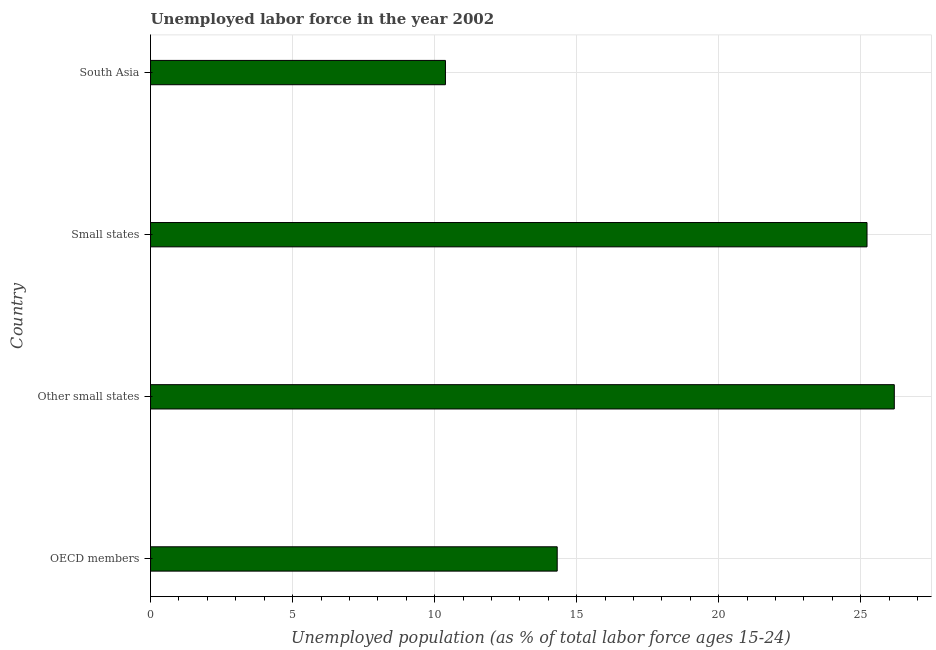Does the graph contain grids?
Your answer should be very brief. Yes. What is the title of the graph?
Give a very brief answer. Unemployed labor force in the year 2002. What is the label or title of the X-axis?
Ensure brevity in your answer.  Unemployed population (as % of total labor force ages 15-24). What is the label or title of the Y-axis?
Give a very brief answer. Country. What is the total unemployed youth population in Other small states?
Offer a very short reply. 26.18. Across all countries, what is the maximum total unemployed youth population?
Make the answer very short. 26.18. Across all countries, what is the minimum total unemployed youth population?
Your response must be concise. 10.38. In which country was the total unemployed youth population maximum?
Your answer should be compact. Other small states. What is the sum of the total unemployed youth population?
Your response must be concise. 76.09. What is the difference between the total unemployed youth population in OECD members and South Asia?
Your answer should be very brief. 3.93. What is the average total unemployed youth population per country?
Ensure brevity in your answer.  19.02. What is the median total unemployed youth population?
Your response must be concise. 19.77. What is the ratio of the total unemployed youth population in OECD members to that in Other small states?
Make the answer very short. 0.55. Is the total unemployed youth population in OECD members less than that in Other small states?
Keep it short and to the point. Yes. Are all the bars in the graph horizontal?
Provide a short and direct response. Yes. What is the difference between two consecutive major ticks on the X-axis?
Your response must be concise. 5. What is the Unemployed population (as % of total labor force ages 15-24) in OECD members?
Provide a succinct answer. 14.31. What is the Unemployed population (as % of total labor force ages 15-24) of Other small states?
Ensure brevity in your answer.  26.18. What is the Unemployed population (as % of total labor force ages 15-24) in Small states?
Provide a succinct answer. 25.22. What is the Unemployed population (as % of total labor force ages 15-24) of South Asia?
Provide a short and direct response. 10.38. What is the difference between the Unemployed population (as % of total labor force ages 15-24) in OECD members and Other small states?
Ensure brevity in your answer.  -11.87. What is the difference between the Unemployed population (as % of total labor force ages 15-24) in OECD members and Small states?
Offer a terse response. -10.91. What is the difference between the Unemployed population (as % of total labor force ages 15-24) in OECD members and South Asia?
Your answer should be very brief. 3.93. What is the difference between the Unemployed population (as % of total labor force ages 15-24) in Other small states and Small states?
Make the answer very short. 0.96. What is the difference between the Unemployed population (as % of total labor force ages 15-24) in Other small states and South Asia?
Make the answer very short. 15.8. What is the difference between the Unemployed population (as % of total labor force ages 15-24) in Small states and South Asia?
Make the answer very short. 14.84. What is the ratio of the Unemployed population (as % of total labor force ages 15-24) in OECD members to that in Other small states?
Offer a terse response. 0.55. What is the ratio of the Unemployed population (as % of total labor force ages 15-24) in OECD members to that in Small states?
Provide a short and direct response. 0.57. What is the ratio of the Unemployed population (as % of total labor force ages 15-24) in OECD members to that in South Asia?
Offer a very short reply. 1.38. What is the ratio of the Unemployed population (as % of total labor force ages 15-24) in Other small states to that in Small states?
Offer a terse response. 1.04. What is the ratio of the Unemployed population (as % of total labor force ages 15-24) in Other small states to that in South Asia?
Provide a succinct answer. 2.52. What is the ratio of the Unemployed population (as % of total labor force ages 15-24) in Small states to that in South Asia?
Provide a short and direct response. 2.43. 